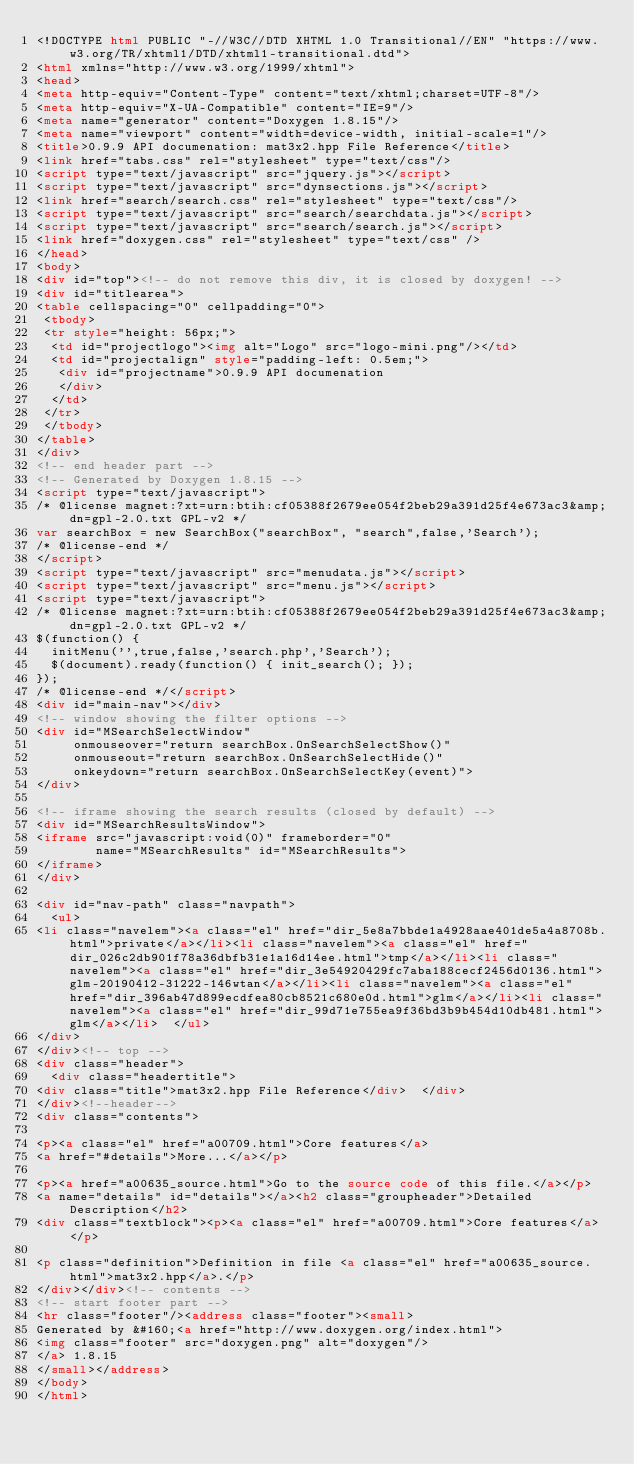<code> <loc_0><loc_0><loc_500><loc_500><_HTML_><!DOCTYPE html PUBLIC "-//W3C//DTD XHTML 1.0 Transitional//EN" "https://www.w3.org/TR/xhtml1/DTD/xhtml1-transitional.dtd">
<html xmlns="http://www.w3.org/1999/xhtml">
<head>
<meta http-equiv="Content-Type" content="text/xhtml;charset=UTF-8"/>
<meta http-equiv="X-UA-Compatible" content="IE=9"/>
<meta name="generator" content="Doxygen 1.8.15"/>
<meta name="viewport" content="width=device-width, initial-scale=1"/>
<title>0.9.9 API documenation: mat3x2.hpp File Reference</title>
<link href="tabs.css" rel="stylesheet" type="text/css"/>
<script type="text/javascript" src="jquery.js"></script>
<script type="text/javascript" src="dynsections.js"></script>
<link href="search/search.css" rel="stylesheet" type="text/css"/>
<script type="text/javascript" src="search/searchdata.js"></script>
<script type="text/javascript" src="search/search.js"></script>
<link href="doxygen.css" rel="stylesheet" type="text/css" />
</head>
<body>
<div id="top"><!-- do not remove this div, it is closed by doxygen! -->
<div id="titlearea">
<table cellspacing="0" cellpadding="0">
 <tbody>
 <tr style="height: 56px;">
  <td id="projectlogo"><img alt="Logo" src="logo-mini.png"/></td>
  <td id="projectalign" style="padding-left: 0.5em;">
   <div id="projectname">0.9.9 API documenation
   </div>
  </td>
 </tr>
 </tbody>
</table>
</div>
<!-- end header part -->
<!-- Generated by Doxygen 1.8.15 -->
<script type="text/javascript">
/* @license magnet:?xt=urn:btih:cf05388f2679ee054f2beb29a391d25f4e673ac3&amp;dn=gpl-2.0.txt GPL-v2 */
var searchBox = new SearchBox("searchBox", "search",false,'Search');
/* @license-end */
</script>
<script type="text/javascript" src="menudata.js"></script>
<script type="text/javascript" src="menu.js"></script>
<script type="text/javascript">
/* @license magnet:?xt=urn:btih:cf05388f2679ee054f2beb29a391d25f4e673ac3&amp;dn=gpl-2.0.txt GPL-v2 */
$(function() {
  initMenu('',true,false,'search.php','Search');
  $(document).ready(function() { init_search(); });
});
/* @license-end */</script>
<div id="main-nav"></div>
<!-- window showing the filter options -->
<div id="MSearchSelectWindow"
     onmouseover="return searchBox.OnSearchSelectShow()"
     onmouseout="return searchBox.OnSearchSelectHide()"
     onkeydown="return searchBox.OnSearchSelectKey(event)">
</div>

<!-- iframe showing the search results (closed by default) -->
<div id="MSearchResultsWindow">
<iframe src="javascript:void(0)" frameborder="0" 
        name="MSearchResults" id="MSearchResults">
</iframe>
</div>

<div id="nav-path" class="navpath">
  <ul>
<li class="navelem"><a class="el" href="dir_5e8a7bbde1a4928aae401de5a4a8708b.html">private</a></li><li class="navelem"><a class="el" href="dir_026c2db901f78a36dbfb31e1a16d14ee.html">tmp</a></li><li class="navelem"><a class="el" href="dir_3e54920429fc7aba188cecf2456d0136.html">glm-20190412-31222-146wtan</a></li><li class="navelem"><a class="el" href="dir_396ab47d899ecdfea80cb8521c680e0d.html">glm</a></li><li class="navelem"><a class="el" href="dir_99d71e755ea9f36bd3b9b454d10db481.html">glm</a></li>  </ul>
</div>
</div><!-- top -->
<div class="header">
  <div class="headertitle">
<div class="title">mat3x2.hpp File Reference</div>  </div>
</div><!--header-->
<div class="contents">

<p><a class="el" href="a00709.html">Core features</a>  
<a href="#details">More...</a></p>

<p><a href="a00635_source.html">Go to the source code of this file.</a></p>
<a name="details" id="details"></a><h2 class="groupheader">Detailed Description</h2>
<div class="textblock"><p><a class="el" href="a00709.html">Core features</a> </p>

<p class="definition">Definition in file <a class="el" href="a00635_source.html">mat3x2.hpp</a>.</p>
</div></div><!-- contents -->
<!-- start footer part -->
<hr class="footer"/><address class="footer"><small>
Generated by &#160;<a href="http://www.doxygen.org/index.html">
<img class="footer" src="doxygen.png" alt="doxygen"/>
</a> 1.8.15
</small></address>
</body>
</html>
</code> 